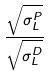<formula> <loc_0><loc_0><loc_500><loc_500>\frac { \sqrt { \sigma _ { L } ^ { P } } } { \sqrt { \sigma _ { L } ^ { D } } }</formula> 